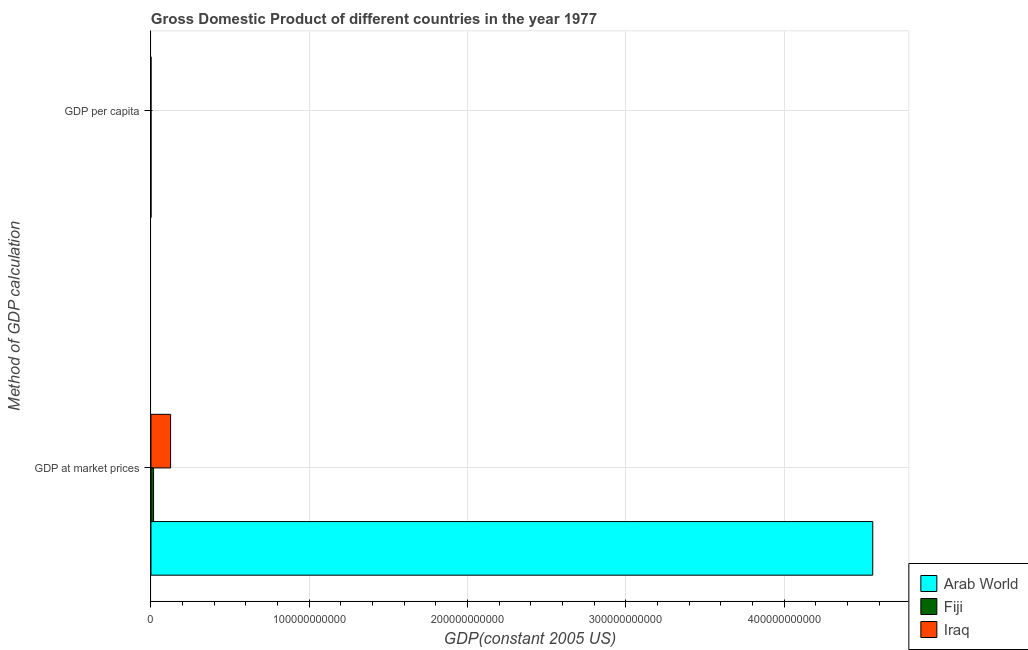How many different coloured bars are there?
Ensure brevity in your answer.  3. How many groups of bars are there?
Your response must be concise. 2. Are the number of bars on each tick of the Y-axis equal?
Offer a terse response. Yes. How many bars are there on the 2nd tick from the top?
Offer a terse response. 3. How many bars are there on the 2nd tick from the bottom?
Offer a terse response. 3. What is the label of the 1st group of bars from the top?
Your answer should be compact. GDP per capita. What is the gdp at market prices in Fiji?
Ensure brevity in your answer.  1.64e+09. Across all countries, what is the maximum gdp per capita?
Offer a terse response. 3056.52. Across all countries, what is the minimum gdp per capita?
Your answer should be very brief. 995.88. In which country was the gdp at market prices maximum?
Make the answer very short. Arab World. In which country was the gdp at market prices minimum?
Offer a terse response. Fiji. What is the total gdp at market prices in the graph?
Provide a short and direct response. 4.70e+11. What is the difference between the gdp per capita in Arab World and that in Fiji?
Provide a succinct answer. 315.17. What is the difference between the gdp at market prices in Fiji and the gdp per capita in Iraq?
Keep it short and to the point. 1.64e+09. What is the average gdp at market prices per country?
Give a very brief answer. 1.57e+11. What is the difference between the gdp at market prices and gdp per capita in Fiji?
Your answer should be very brief. 1.64e+09. What is the ratio of the gdp per capita in Fiji to that in Iraq?
Offer a terse response. 2.75. In how many countries, is the gdp at market prices greater than the average gdp at market prices taken over all countries?
Provide a succinct answer. 1. What does the 2nd bar from the top in GDP at market prices represents?
Ensure brevity in your answer.  Fiji. What does the 2nd bar from the bottom in GDP at market prices represents?
Ensure brevity in your answer.  Fiji. Are all the bars in the graph horizontal?
Provide a short and direct response. Yes. What is the difference between two consecutive major ticks on the X-axis?
Keep it short and to the point. 1.00e+11. Are the values on the major ticks of X-axis written in scientific E-notation?
Keep it short and to the point. No. Does the graph contain any zero values?
Keep it short and to the point. No. Does the graph contain grids?
Provide a succinct answer. Yes. What is the title of the graph?
Provide a succinct answer. Gross Domestic Product of different countries in the year 1977. What is the label or title of the X-axis?
Offer a terse response. GDP(constant 2005 US). What is the label or title of the Y-axis?
Offer a very short reply. Method of GDP calculation. What is the GDP(constant 2005 US) of Arab World in GDP at market prices?
Give a very brief answer. 4.56e+11. What is the GDP(constant 2005 US) of Fiji in GDP at market prices?
Give a very brief answer. 1.64e+09. What is the GDP(constant 2005 US) of Iraq in GDP at market prices?
Keep it short and to the point. 1.24e+1. What is the GDP(constant 2005 US) of Arab World in GDP per capita?
Offer a very short reply. 3056.52. What is the GDP(constant 2005 US) in Fiji in GDP per capita?
Ensure brevity in your answer.  2741.35. What is the GDP(constant 2005 US) of Iraq in GDP per capita?
Offer a terse response. 995.88. Across all Method of GDP calculation, what is the maximum GDP(constant 2005 US) in Arab World?
Offer a terse response. 4.56e+11. Across all Method of GDP calculation, what is the maximum GDP(constant 2005 US) of Fiji?
Give a very brief answer. 1.64e+09. Across all Method of GDP calculation, what is the maximum GDP(constant 2005 US) of Iraq?
Your response must be concise. 1.24e+1. Across all Method of GDP calculation, what is the minimum GDP(constant 2005 US) in Arab World?
Ensure brevity in your answer.  3056.52. Across all Method of GDP calculation, what is the minimum GDP(constant 2005 US) of Fiji?
Ensure brevity in your answer.  2741.35. Across all Method of GDP calculation, what is the minimum GDP(constant 2005 US) in Iraq?
Provide a succinct answer. 995.88. What is the total GDP(constant 2005 US) in Arab World in the graph?
Your answer should be very brief. 4.56e+11. What is the total GDP(constant 2005 US) in Fiji in the graph?
Keep it short and to the point. 1.64e+09. What is the total GDP(constant 2005 US) in Iraq in the graph?
Your answer should be compact. 1.24e+1. What is the difference between the GDP(constant 2005 US) in Arab World in GDP at market prices and that in GDP per capita?
Give a very brief answer. 4.56e+11. What is the difference between the GDP(constant 2005 US) in Fiji in GDP at market prices and that in GDP per capita?
Your answer should be very brief. 1.64e+09. What is the difference between the GDP(constant 2005 US) of Iraq in GDP at market prices and that in GDP per capita?
Your answer should be compact. 1.24e+1. What is the difference between the GDP(constant 2005 US) in Arab World in GDP at market prices and the GDP(constant 2005 US) in Fiji in GDP per capita?
Offer a very short reply. 4.56e+11. What is the difference between the GDP(constant 2005 US) of Arab World in GDP at market prices and the GDP(constant 2005 US) of Iraq in GDP per capita?
Provide a succinct answer. 4.56e+11. What is the difference between the GDP(constant 2005 US) of Fiji in GDP at market prices and the GDP(constant 2005 US) of Iraq in GDP per capita?
Offer a very short reply. 1.64e+09. What is the average GDP(constant 2005 US) of Arab World per Method of GDP calculation?
Make the answer very short. 2.28e+11. What is the average GDP(constant 2005 US) in Fiji per Method of GDP calculation?
Your answer should be compact. 8.20e+08. What is the average GDP(constant 2005 US) in Iraq per Method of GDP calculation?
Keep it short and to the point. 6.20e+09. What is the difference between the GDP(constant 2005 US) in Arab World and GDP(constant 2005 US) in Fiji in GDP at market prices?
Offer a very short reply. 4.54e+11. What is the difference between the GDP(constant 2005 US) of Arab World and GDP(constant 2005 US) of Iraq in GDP at market prices?
Your answer should be compact. 4.43e+11. What is the difference between the GDP(constant 2005 US) of Fiji and GDP(constant 2005 US) of Iraq in GDP at market prices?
Keep it short and to the point. -1.08e+1. What is the difference between the GDP(constant 2005 US) in Arab World and GDP(constant 2005 US) in Fiji in GDP per capita?
Keep it short and to the point. 315.17. What is the difference between the GDP(constant 2005 US) of Arab World and GDP(constant 2005 US) of Iraq in GDP per capita?
Ensure brevity in your answer.  2060.64. What is the difference between the GDP(constant 2005 US) of Fiji and GDP(constant 2005 US) of Iraq in GDP per capita?
Ensure brevity in your answer.  1745.48. What is the ratio of the GDP(constant 2005 US) in Arab World in GDP at market prices to that in GDP per capita?
Offer a very short reply. 1.49e+08. What is the ratio of the GDP(constant 2005 US) of Fiji in GDP at market prices to that in GDP per capita?
Provide a short and direct response. 5.98e+05. What is the ratio of the GDP(constant 2005 US) of Iraq in GDP at market prices to that in GDP per capita?
Your answer should be compact. 1.25e+07. What is the difference between the highest and the second highest GDP(constant 2005 US) of Arab World?
Ensure brevity in your answer.  4.56e+11. What is the difference between the highest and the second highest GDP(constant 2005 US) of Fiji?
Your answer should be compact. 1.64e+09. What is the difference between the highest and the second highest GDP(constant 2005 US) in Iraq?
Make the answer very short. 1.24e+1. What is the difference between the highest and the lowest GDP(constant 2005 US) of Arab World?
Make the answer very short. 4.56e+11. What is the difference between the highest and the lowest GDP(constant 2005 US) in Fiji?
Offer a terse response. 1.64e+09. What is the difference between the highest and the lowest GDP(constant 2005 US) of Iraq?
Ensure brevity in your answer.  1.24e+1. 